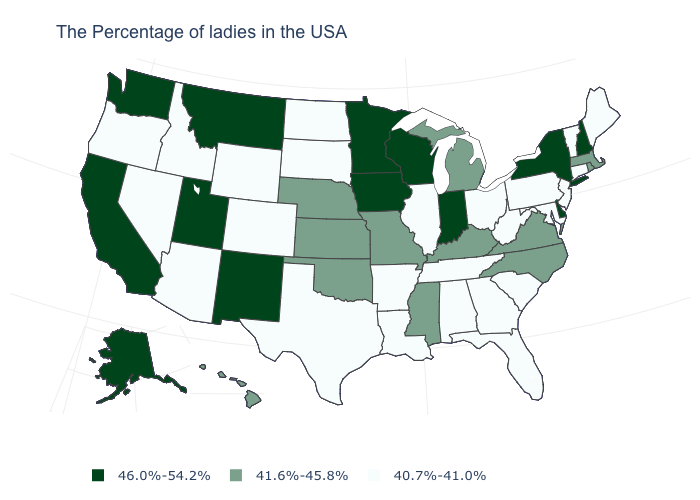Is the legend a continuous bar?
Be succinct. No. Is the legend a continuous bar?
Concise answer only. No. Is the legend a continuous bar?
Answer briefly. No. What is the highest value in the West ?
Short answer required. 46.0%-54.2%. Which states hav the highest value in the MidWest?
Answer briefly. Indiana, Wisconsin, Minnesota, Iowa. What is the value of Oklahoma?
Write a very short answer. 41.6%-45.8%. What is the highest value in the USA?
Quick response, please. 46.0%-54.2%. Does South Dakota have the highest value in the MidWest?
Be succinct. No. What is the highest value in the USA?
Answer briefly. 46.0%-54.2%. What is the value of Alabama?
Give a very brief answer. 40.7%-41.0%. Name the states that have a value in the range 40.7%-41.0%?
Keep it brief. Maine, Vermont, Connecticut, New Jersey, Maryland, Pennsylvania, South Carolina, West Virginia, Ohio, Florida, Georgia, Alabama, Tennessee, Illinois, Louisiana, Arkansas, Texas, South Dakota, North Dakota, Wyoming, Colorado, Arizona, Idaho, Nevada, Oregon. Name the states that have a value in the range 41.6%-45.8%?
Write a very short answer. Massachusetts, Rhode Island, Virginia, North Carolina, Michigan, Kentucky, Mississippi, Missouri, Kansas, Nebraska, Oklahoma, Hawaii. Which states have the lowest value in the USA?
Short answer required. Maine, Vermont, Connecticut, New Jersey, Maryland, Pennsylvania, South Carolina, West Virginia, Ohio, Florida, Georgia, Alabama, Tennessee, Illinois, Louisiana, Arkansas, Texas, South Dakota, North Dakota, Wyoming, Colorado, Arizona, Idaho, Nevada, Oregon. Does Louisiana have the same value as Florida?
Write a very short answer. Yes. Name the states that have a value in the range 41.6%-45.8%?
Keep it brief. Massachusetts, Rhode Island, Virginia, North Carolina, Michigan, Kentucky, Mississippi, Missouri, Kansas, Nebraska, Oklahoma, Hawaii. 